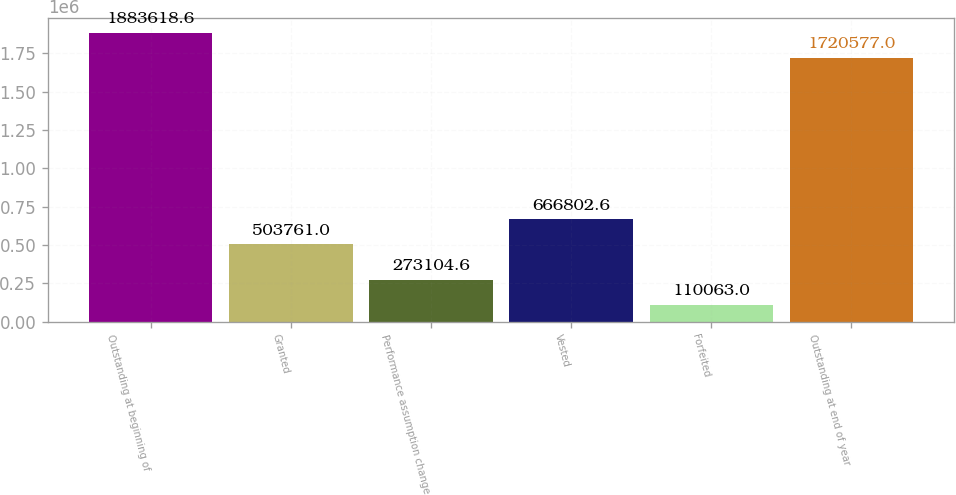Convert chart to OTSL. <chart><loc_0><loc_0><loc_500><loc_500><bar_chart><fcel>Outstanding at beginning of<fcel>Granted<fcel>Performance assumption change<fcel>Vested<fcel>Forfeited<fcel>Outstanding at end of year<nl><fcel>1.88362e+06<fcel>503761<fcel>273105<fcel>666803<fcel>110063<fcel>1.72058e+06<nl></chart> 